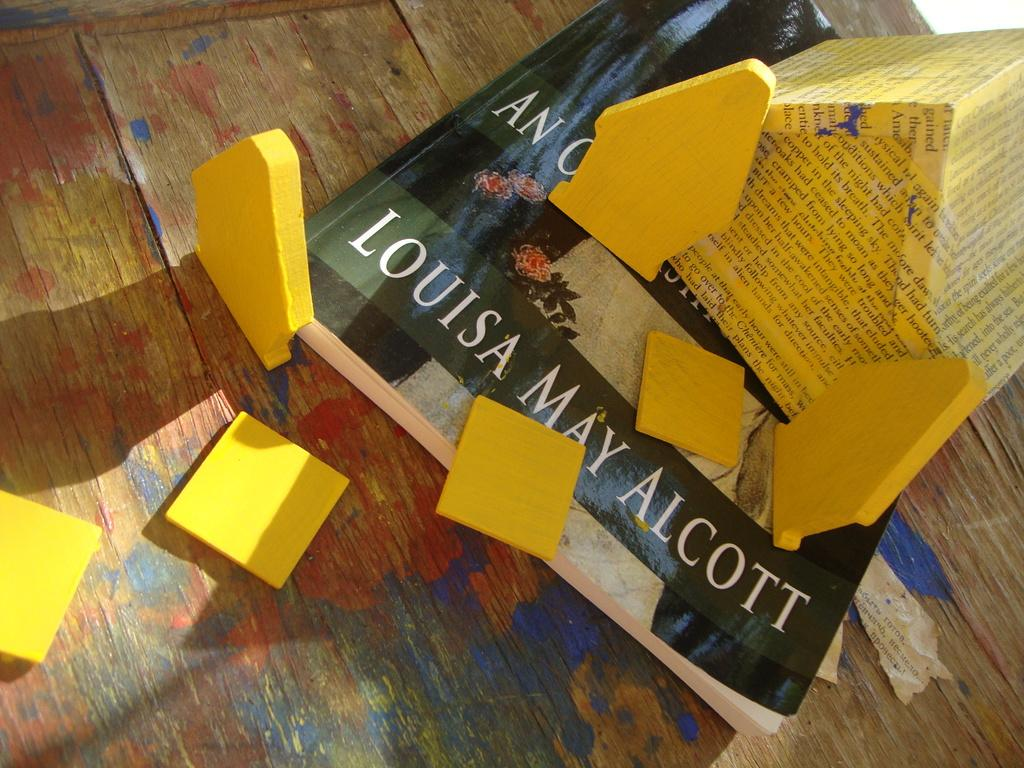Provide a one-sentence caption for the provided image. A book that is by Lousia May Alcott with post it around the book on the wood floor. 